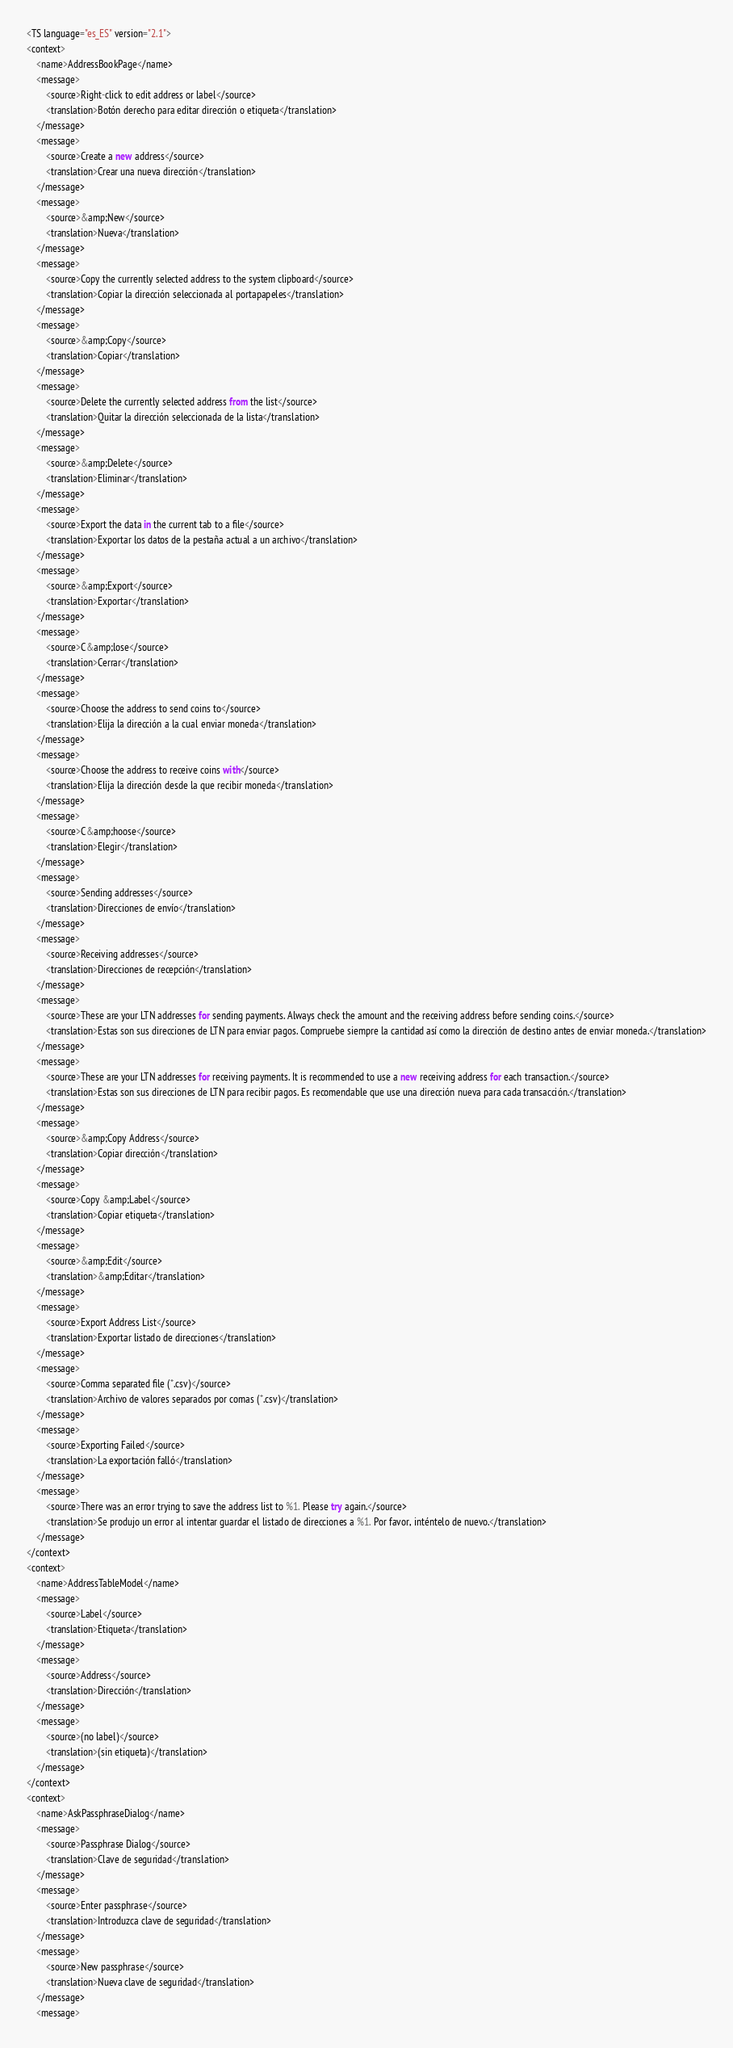<code> <loc_0><loc_0><loc_500><loc_500><_TypeScript_><TS language="es_ES" version="2.1">
<context>
    <name>AddressBookPage</name>
    <message>
        <source>Right-click to edit address or label</source>
        <translation>Botón derecho para editar dirección o etiqueta</translation>
    </message>
    <message>
        <source>Create a new address</source>
        <translation>Crear una nueva dirección</translation>
    </message>
    <message>
        <source>&amp;New</source>
        <translation>Nueva</translation>
    </message>
    <message>
        <source>Copy the currently selected address to the system clipboard</source>
        <translation>Copiar la dirección seleccionada al portapapeles</translation>
    </message>
    <message>
        <source>&amp;Copy</source>
        <translation>Copiar</translation>
    </message>
    <message>
        <source>Delete the currently selected address from the list</source>
        <translation>Quitar la dirección seleccionada de la lista</translation>
    </message>
    <message>
        <source>&amp;Delete</source>
        <translation>Eliminar</translation>
    </message>
    <message>
        <source>Export the data in the current tab to a file</source>
        <translation>Exportar los datos de la pestaña actual a un archivo</translation>
    </message>
    <message>
        <source>&amp;Export</source>
        <translation>Exportar</translation>
    </message>
    <message>
        <source>C&amp;lose</source>
        <translation>Cerrar</translation>
    </message>
    <message>
        <source>Choose the address to send coins to</source>
        <translation>Elija la dirección a la cual enviar moneda</translation>
    </message>
    <message>
        <source>Choose the address to receive coins with</source>
        <translation>Elija la dirección desde la que recibir moneda</translation>
    </message>
    <message>
        <source>C&amp;hoose</source>
        <translation>Elegir</translation>
    </message>
    <message>
        <source>Sending addresses</source>
        <translation>Direcciones de envío</translation>
    </message>
    <message>
        <source>Receiving addresses</source>
        <translation>Direcciones de recepción</translation>
    </message>
    <message>
        <source>These are your LTN addresses for sending payments. Always check the amount and the receiving address before sending coins.</source>
        <translation>Estas son sus direcciones de LTN para enviar pagos. Compruebe siempre la cantidad así como la dirección de destino antes de enviar moneda.</translation>
    </message>
    <message>
        <source>These are your LTN addresses for receiving payments. It is recommended to use a new receiving address for each transaction.</source>
        <translation>Estas son sus direcciones de LTN para recibir pagos. Es recomendable que use una dirección nueva para cada transacción.</translation>
    </message>
    <message>
        <source>&amp;Copy Address</source>
        <translation>Copiar dirección</translation>
    </message>
    <message>
        <source>Copy &amp;Label</source>
        <translation>Copiar etiqueta</translation>
    </message>
    <message>
        <source>&amp;Edit</source>
        <translation>&amp;Editar</translation>
    </message>
    <message>
        <source>Export Address List</source>
        <translation>Exportar listado de direcciones</translation>
    </message>
    <message>
        <source>Comma separated file (*.csv)</source>
        <translation>Archivo de valores separados por comas (*.csv)</translation>
    </message>
    <message>
        <source>Exporting Failed</source>
        <translation>La exportación falló</translation>
    </message>
    <message>
        <source>There was an error trying to save the address list to %1. Please try again.</source>
        <translation>Se produjo un error al intentar guardar el listado de direcciones a %1. Por favor, inténtelo de nuevo.</translation>
    </message>
</context>
<context>
    <name>AddressTableModel</name>
    <message>
        <source>Label</source>
        <translation>Etiqueta</translation>
    </message>
    <message>
        <source>Address</source>
        <translation>Dirección</translation>
    </message>
    <message>
        <source>(no label)</source>
        <translation>(sin etiqueta)</translation>
    </message>
</context>
<context>
    <name>AskPassphraseDialog</name>
    <message>
        <source>Passphrase Dialog</source>
        <translation>Clave de seguridad</translation>
    </message>
    <message>
        <source>Enter passphrase</source>
        <translation>Introduzca clave de seguridad</translation>
    </message>
    <message>
        <source>New passphrase</source>
        <translation>Nueva clave de seguridad</translation>
    </message>
    <message></code> 